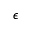Convert formula to latex. <formula><loc_0><loc_0><loc_500><loc_500>\epsilon</formula> 